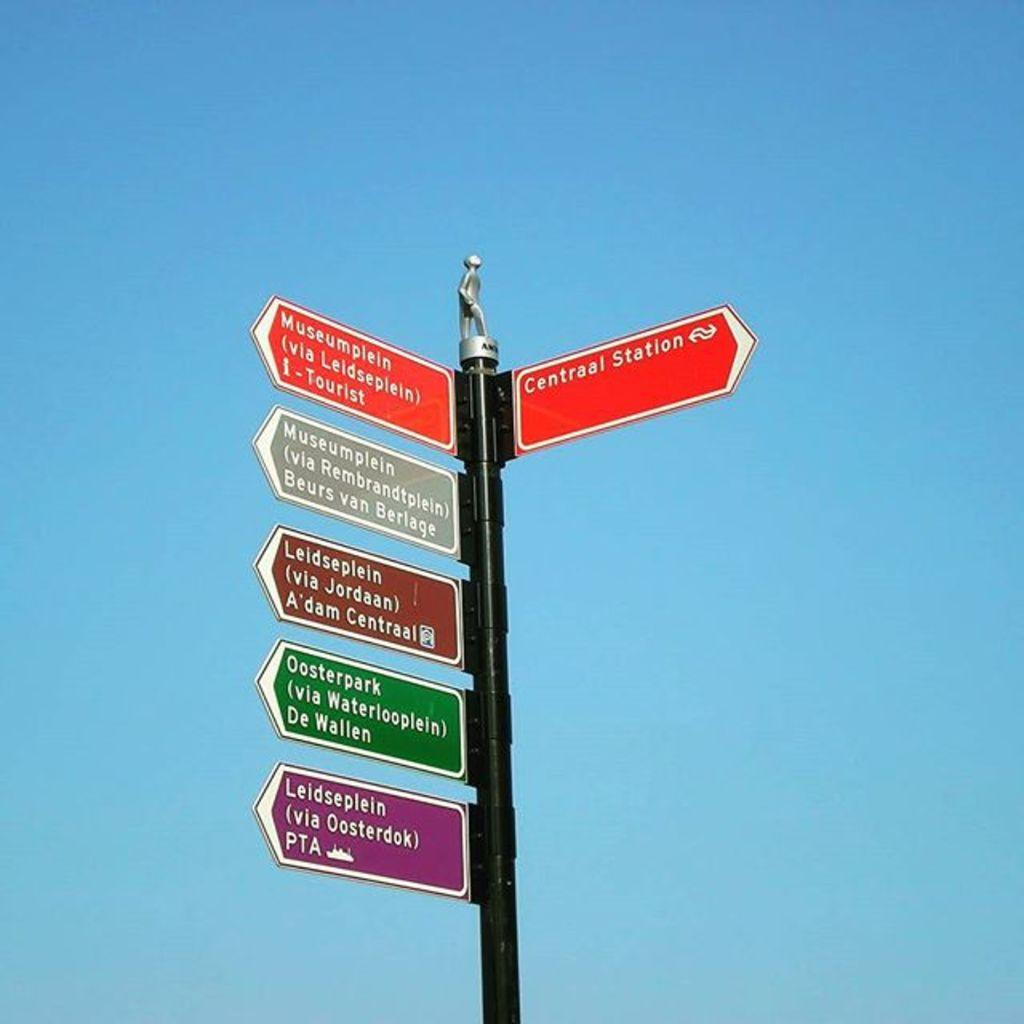<image>
Render a clear and concise summary of the photo. Several signs are on a black pole and one of them says Centraal Station. 